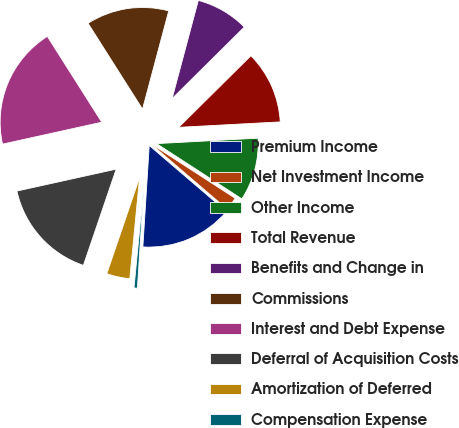Convert chart. <chart><loc_0><loc_0><loc_500><loc_500><pie_chart><fcel>Premium Income<fcel>Net Investment Income<fcel>Other Income<fcel>Total Revenue<fcel>Benefits and Change in<fcel>Commissions<fcel>Interest and Debt Expense<fcel>Deferral of Acquisition Costs<fcel>Amortization of Deferred<fcel>Compensation Expense<nl><fcel>14.73%<fcel>2.12%<fcel>10.0%<fcel>11.58%<fcel>8.42%<fcel>13.15%<fcel>19.46%<fcel>16.31%<fcel>3.69%<fcel>0.54%<nl></chart> 